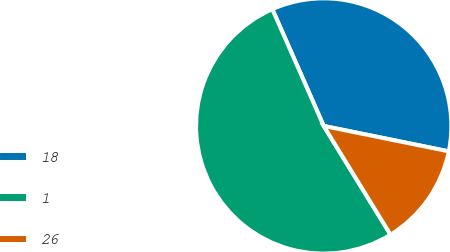<chart> <loc_0><loc_0><loc_500><loc_500><pie_chart><fcel>18<fcel>1<fcel>26<nl><fcel>34.78%<fcel>52.17%<fcel>13.04%<nl></chart> 